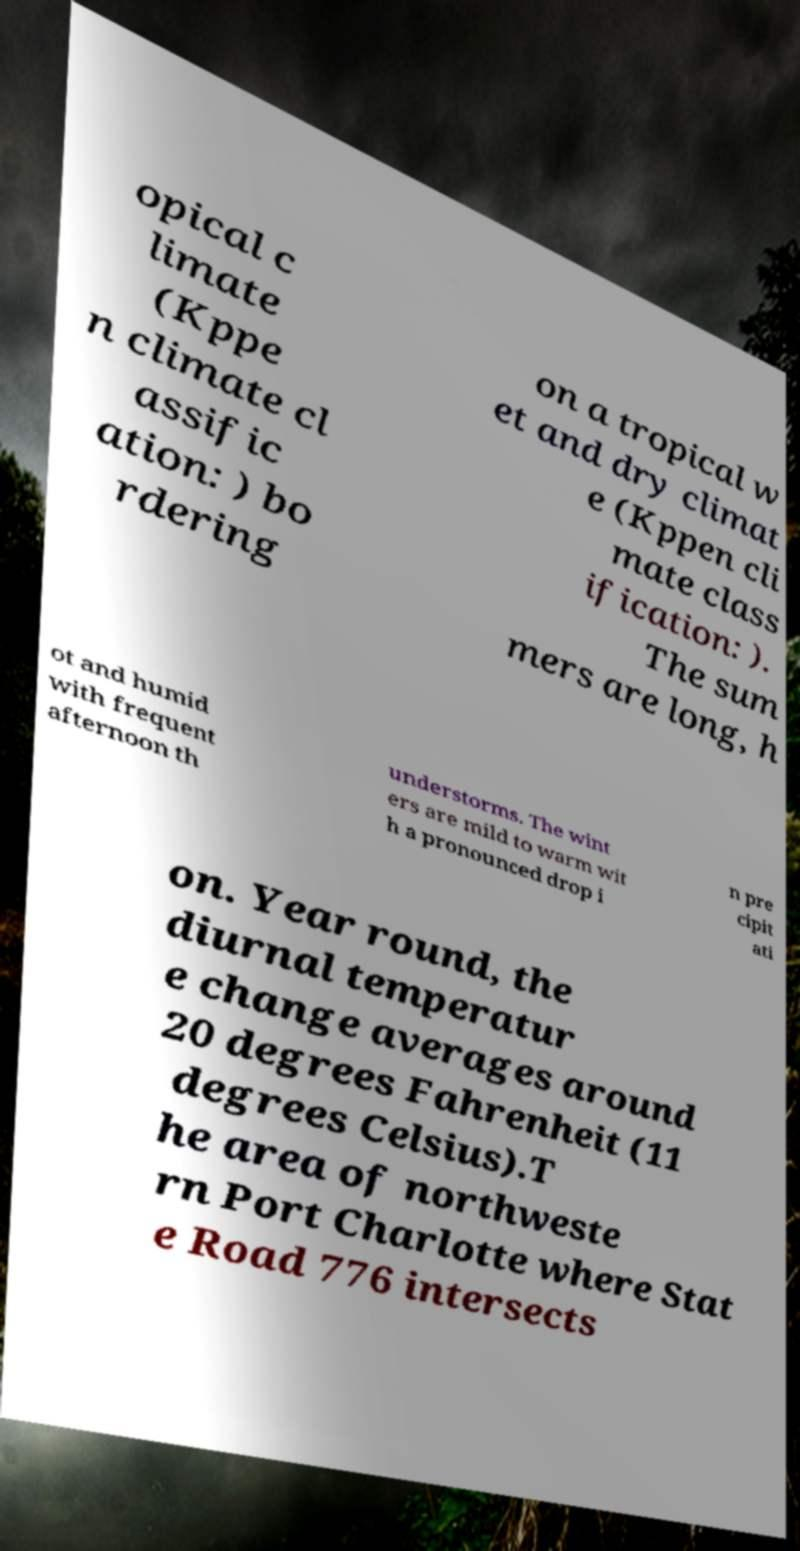I need the written content from this picture converted into text. Can you do that? opical c limate (Kppe n climate cl assific ation: ) bo rdering on a tropical w et and dry climat e (Kppen cli mate class ification: ). The sum mers are long, h ot and humid with frequent afternoon th understorms. The wint ers are mild to warm wit h a pronounced drop i n pre cipit ati on. Year round, the diurnal temperatur e change averages around 20 degrees Fahrenheit (11 degrees Celsius).T he area of northweste rn Port Charlotte where Stat e Road 776 intersects 